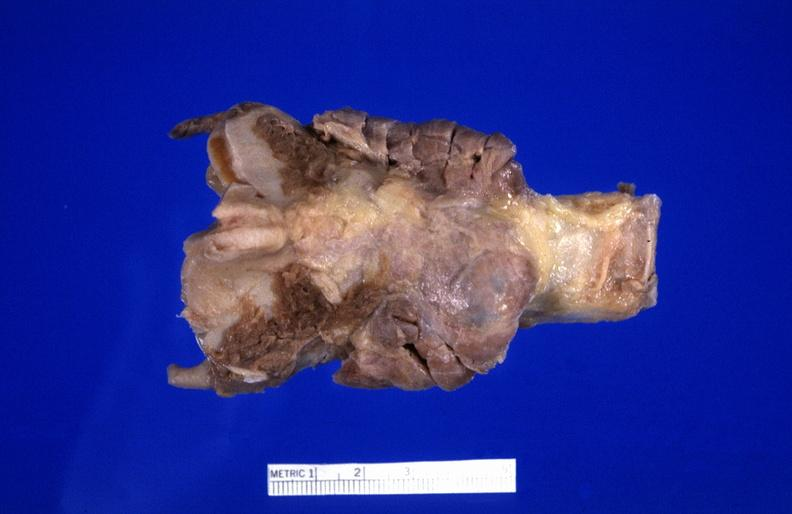does marked show hashimoto 's thyroiditis?
Answer the question using a single word or phrase. No 